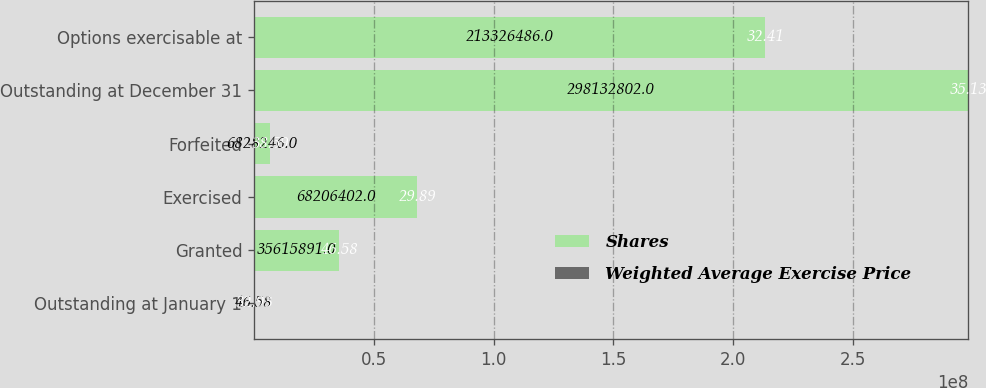<chart> <loc_0><loc_0><loc_500><loc_500><stacked_bar_chart><ecel><fcel>Outstanding at January 1<fcel>Granted<fcel>Exercised<fcel>Forfeited<fcel>Outstanding at December 31<fcel>Options exercisable at<nl><fcel>Shares<fcel>46.58<fcel>3.56159e+07<fcel>6.82064e+07<fcel>6.82825e+06<fcel>2.98133e+08<fcel>2.13326e+08<nl><fcel>Weighted Average Exercise Price<fcel>32.93<fcel>46.58<fcel>29.89<fcel>38.59<fcel>35.13<fcel>32.41<nl></chart> 